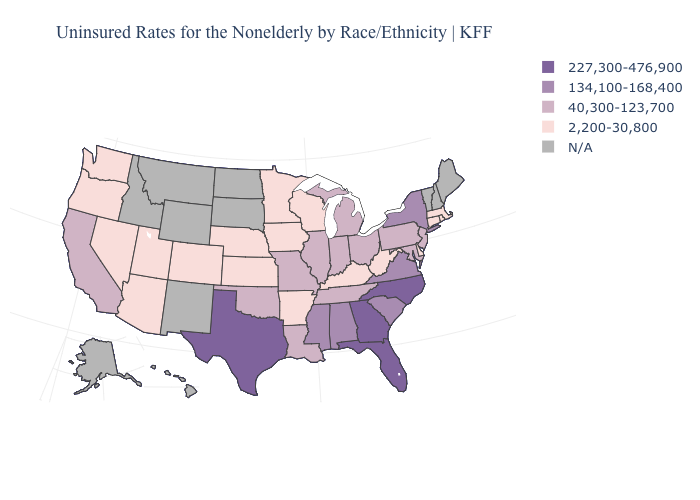Which states have the lowest value in the USA?
Give a very brief answer. Arizona, Arkansas, Colorado, Connecticut, Delaware, Iowa, Kansas, Kentucky, Massachusetts, Minnesota, Nebraska, Nevada, Oregon, Rhode Island, Utah, Washington, West Virginia, Wisconsin. What is the value of Nebraska?
Write a very short answer. 2,200-30,800. Does Florida have the highest value in the USA?
Answer briefly. Yes. Among the states that border Connecticut , which have the highest value?
Answer briefly. New York. What is the value of North Dakota?
Write a very short answer. N/A. Does Arizona have the highest value in the West?
Short answer required. No. Which states hav the highest value in the West?
Give a very brief answer. California. Which states have the lowest value in the MidWest?
Answer briefly. Iowa, Kansas, Minnesota, Nebraska, Wisconsin. Does Illinois have the highest value in the MidWest?
Give a very brief answer. Yes. What is the value of Oklahoma?
Short answer required. 40,300-123,700. What is the lowest value in the South?
Quick response, please. 2,200-30,800. Does Louisiana have the highest value in the USA?
Keep it brief. No. What is the value of Oregon?
Answer briefly. 2,200-30,800. What is the value of Georgia?
Be succinct. 227,300-476,900. 